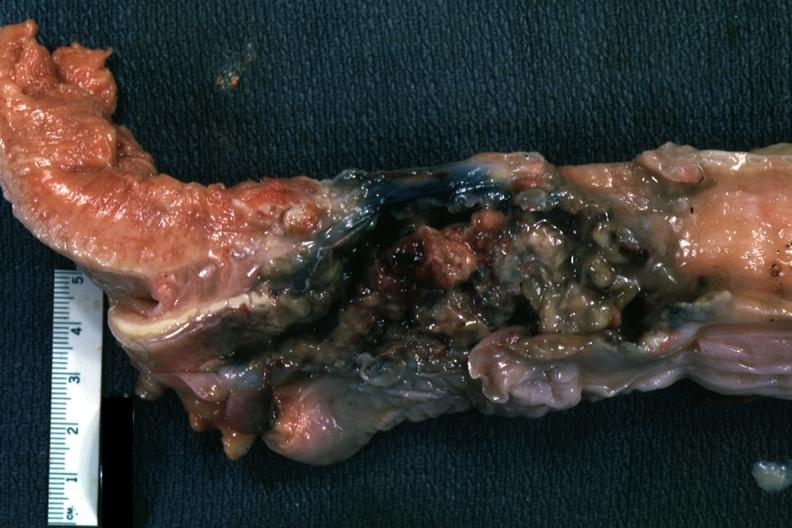what is mass of necrotic tissue?
Answer the question using a single word or phrase. Larynx 